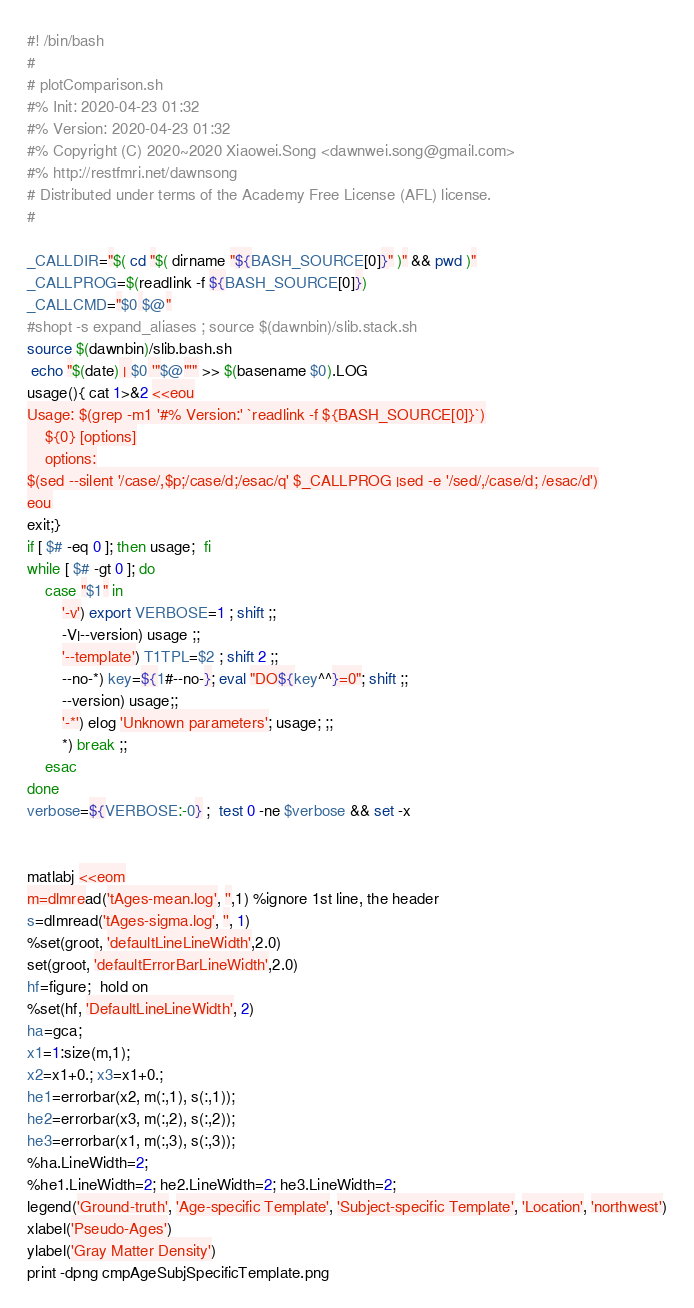<code> <loc_0><loc_0><loc_500><loc_500><_Bash_>#! /bin/bash
#
# plotComparison.sh
#% Init: 2020-04-23 01:32
#% Version: 2020-04-23 01:32
#% Copyright (C) 2020~2020 Xiaowei.Song <dawnwei.song@gmail.com>
#% http://restfmri.net/dawnsong
# Distributed under terms of the Academy Free License (AFL) license.
#

_CALLDIR="$( cd "$( dirname "${BASH_SOURCE[0]}" )" && pwd )"
_CALLPROG=$(readlink -f ${BASH_SOURCE[0]})
_CALLCMD="$0 $@"
#shopt -s expand_aliases ; source $(dawnbin)/slib.stack.sh
source $(dawnbin)/slib.bash.sh
 echo "$(date) | $0 '"$@"'" >> $(basename $0).LOG
usage(){ cat 1>&2 <<eou
Usage: $(grep -m1 '#% Version:' `readlink -f ${BASH_SOURCE[0]}`)
    ${0} [options]
    options:
$(sed --silent '/case/,$p;/case/d;/esac/q' $_CALLPROG |sed -e '/sed/,/case/d; /esac/d')
eou
exit;}
if [ $# -eq 0 ]; then usage;  fi
while [ $# -gt 0 ]; do
    case "$1" in
        '-v') export VERBOSE=1 ; shift ;;
        -V|--version) usage ;;
        '--template') T1TPL=$2 ; shift 2 ;;
        --no-*) key=${1#--no-}; eval "DO${key^^}=0"; shift ;;
        --version) usage;;
        '-*') elog 'Unknown parameters'; usage; ;;
        *) break ;;
    esac
done
verbose=${VERBOSE:-0} ;  test 0 -ne $verbose && set -x


matlabj <<eom
m=dlmread('tAges-mean.log', '',1) %ignore 1st line, the header
s=dlmread('tAges-sigma.log', '', 1)
%set(groot, 'defaultLineLineWidth',2.0)
set(groot, 'defaultErrorBarLineWidth',2.0)
hf=figure;  hold on
%set(hf, 'DefaultLineLineWidth', 2)
ha=gca;
x1=1:size(m,1);
x2=x1+0.; x3=x1+0.;
he1=errorbar(x2, m(:,1), s(:,1));
he2=errorbar(x3, m(:,2), s(:,2));
he3=errorbar(x1, m(:,3), s(:,3));
%ha.LineWidth=2;
%he1.LineWidth=2; he2.LineWidth=2; he3.LineWidth=2;
legend('Ground-truth', 'Age-specific Template', 'Subject-specific Template', 'Location', 'northwest')
xlabel('Pseudo-Ages')
ylabel('Gray Matter Density')
print -dpng cmpAgeSubjSpecificTemplate.png</code> 